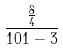Convert formula to latex. <formula><loc_0><loc_0><loc_500><loc_500>\frac { \frac { 8 } { 4 } } { 1 0 1 - 3 }</formula> 